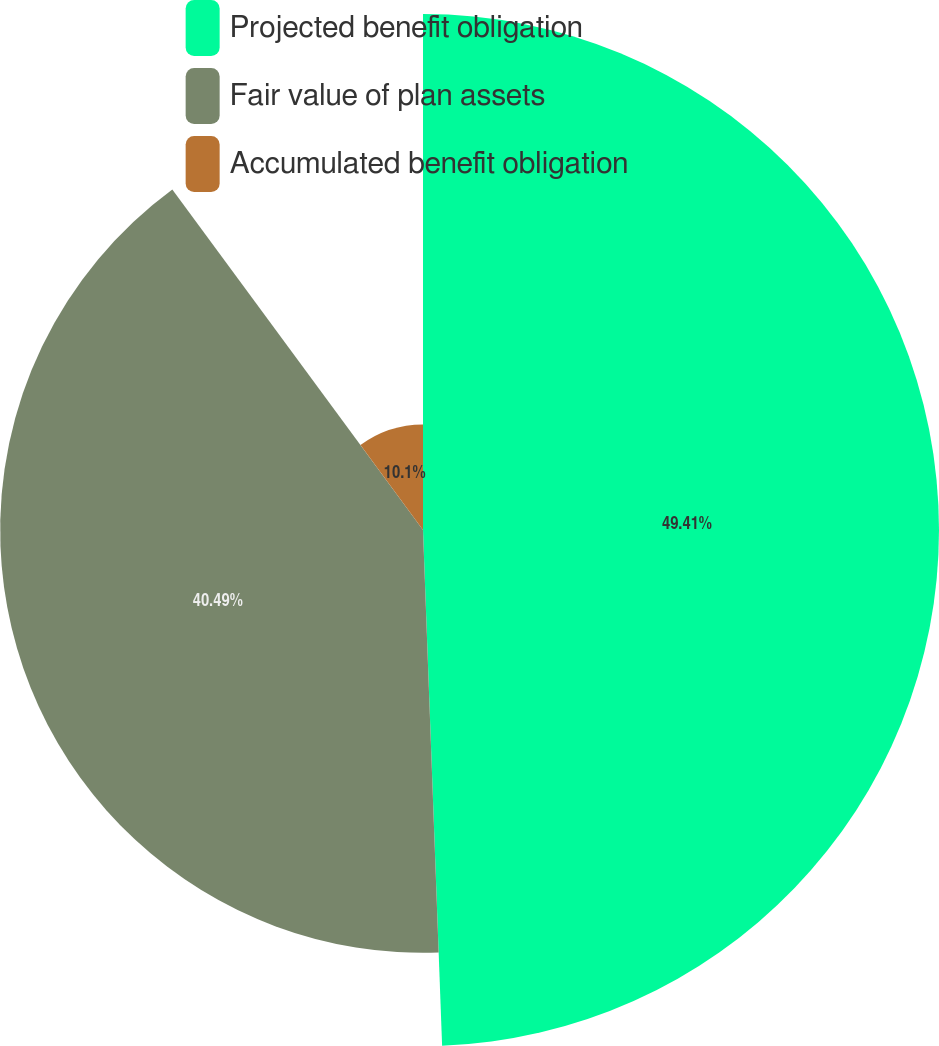Convert chart to OTSL. <chart><loc_0><loc_0><loc_500><loc_500><pie_chart><fcel>Projected benefit obligation<fcel>Fair value of plan assets<fcel>Accumulated benefit obligation<nl><fcel>49.41%<fcel>40.49%<fcel>10.1%<nl></chart> 